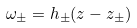<formula> <loc_0><loc_0><loc_500><loc_500>\omega _ { \pm } = h _ { \pm } ( z - z _ { \pm } )</formula> 